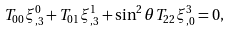<formula> <loc_0><loc_0><loc_500><loc_500>T _ { 0 0 } \xi ^ { 0 } _ { , 3 } + T _ { 0 1 } \xi ^ { 1 } _ { , 3 } + \sin ^ { 2 } \theta T _ { 2 2 } \xi ^ { 3 } _ { , 0 } = 0 ,</formula> 